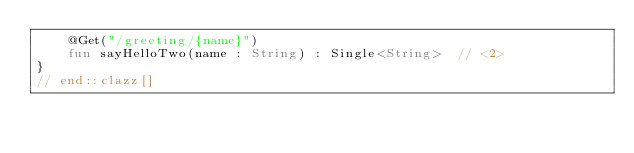Convert code to text. <code><loc_0><loc_0><loc_500><loc_500><_Kotlin_>    @Get("/greeting/{name}")
    fun sayHelloTwo(name : String) : Single<String>  // <2>
}
// end::clazz[]
</code> 